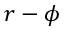<formula> <loc_0><loc_0><loc_500><loc_500>r - \phi</formula> 